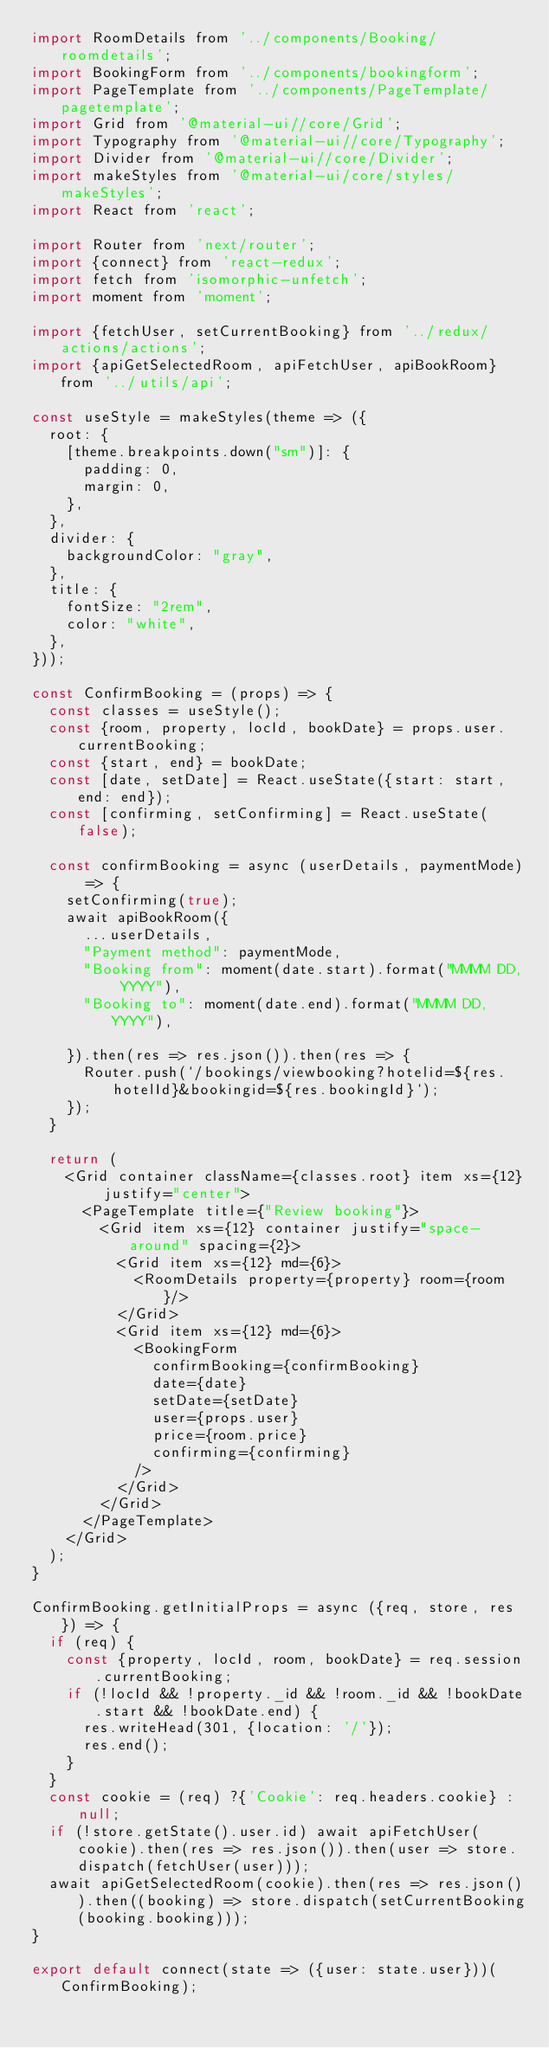<code> <loc_0><loc_0><loc_500><loc_500><_JavaScript_>import RoomDetails from '../components/Booking/roomdetails';
import BookingForm from '../components/bookingform';
import PageTemplate from '../components/PageTemplate/pagetemplate';
import Grid from '@material-ui//core/Grid';
import Typography from '@material-ui//core/Typography';
import Divider from '@material-ui//core/Divider';
import makeStyles from '@material-ui/core/styles/makeStyles';
import React from 'react';

import Router from 'next/router';
import {connect} from 'react-redux';
import fetch from 'isomorphic-unfetch';
import moment from 'moment';

import {fetchUser, setCurrentBooking} from '../redux/actions/actions';
import {apiGetSelectedRoom, apiFetchUser, apiBookRoom} from '../utils/api';

const useStyle = makeStyles(theme => ({
	root: {
		[theme.breakpoints.down("sm")]: {
			padding: 0,
			margin: 0,
		},
	},
	divider: {
		backgroundColor: "gray",
	},
	title: {
		fontSize: "2rem",
		color: "white",
	},
}));

const ConfirmBooking = (props) => {
	const classes = useStyle();
	const {room, property, locId, bookDate} = props.user.currentBooking;
	const {start, end} = bookDate;
	const [date, setDate] = React.useState({start: start, end: end});
	const [confirming, setConfirming] = React.useState(false);
	
	const confirmBooking = async (userDetails, paymentMode) => {
		setConfirming(true);
		await apiBookRoom({
			...userDetails,
			"Payment method": paymentMode,
			"Booking from": moment(date.start).format("MMMM DD, YYYY"),
			"Booking to": moment(date.end).format("MMMM DD, YYYY"), 

		}).then(res => res.json()).then(res => {
			Router.push(`/bookings/viewbooking?hotelid=${res.hotelId}&bookingid=${res.bookingId}`);
		});
	}

	return (
		<Grid container className={classes.root} item xs={12} justify="center">
			<PageTemplate title={"Review booking"}>
				<Grid item xs={12} container justify="space-around" spacing={2}>
					<Grid item xs={12} md={6}>
						<RoomDetails property={property} room={room}/>
					</Grid>
					<Grid item xs={12} md={6}>
						<BookingForm 
							confirmBooking={confirmBooking} 
							date={date}
							setDate={setDate} 
							user={props.user}
							price={room.price}
							confirming={confirming}
						/>
					</Grid>
				</Grid>
			</PageTemplate>
		</Grid>
	);
}

ConfirmBooking.getInitialProps = async ({req, store, res}) => {
	if (req) {
		const {property, locId, room, bookDate} = req.session.currentBooking;
		if (!locId && !property._id && !room._id && !bookDate.start && !bookDate.end) {
			res.writeHead(301, {location: '/'});
			res.end();
		}
	}
	const cookie = (req) ?{'Cookie': req.headers.cookie} :null;
	if (!store.getState().user.id) await apiFetchUser(cookie).then(res => res.json()).then(user => store.dispatch(fetchUser(user)));
	await apiGetSelectedRoom(cookie).then(res => res.json()).then((booking) => store.dispatch(setCurrentBooking(booking.booking)));
}

export default connect(state => ({user: state.user}))(ConfirmBooking);</code> 